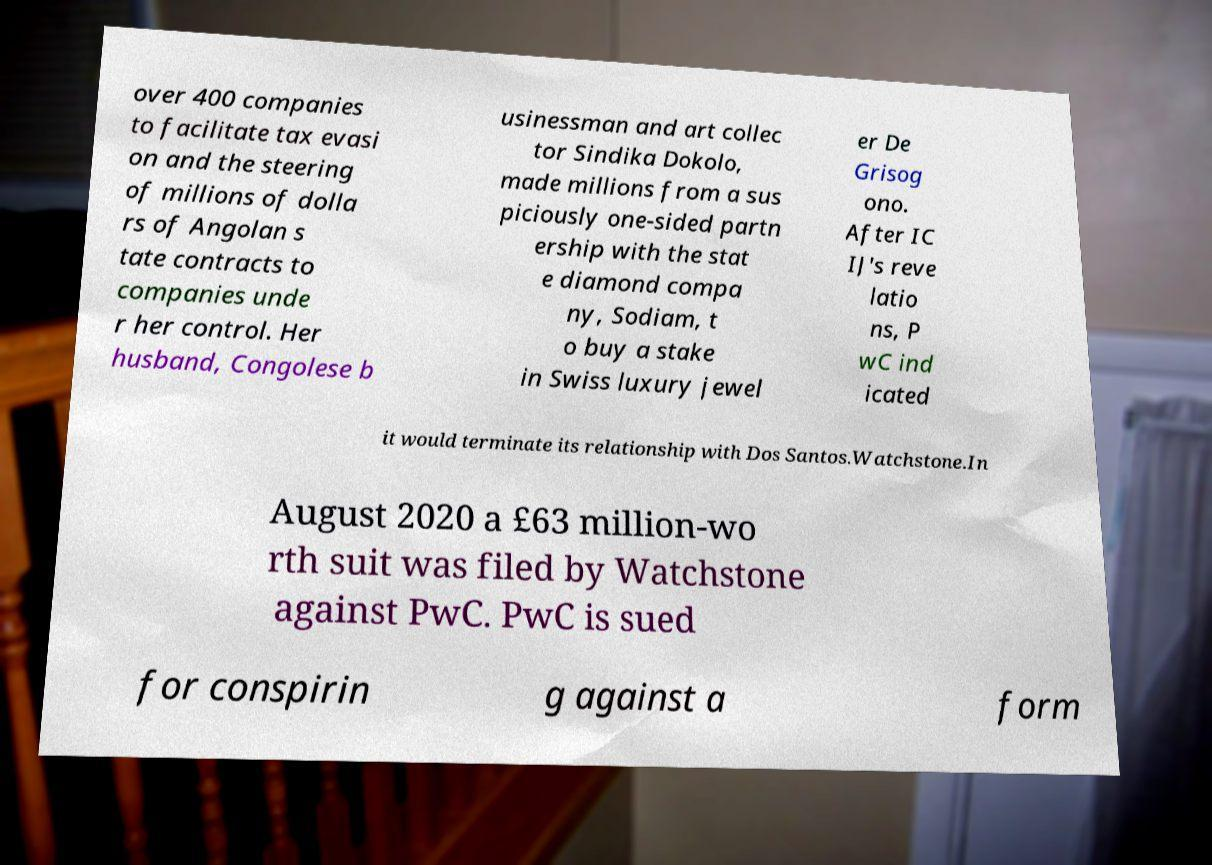Can you accurately transcribe the text from the provided image for me? over 400 companies to facilitate tax evasi on and the steering of millions of dolla rs of Angolan s tate contracts to companies unde r her control. Her husband, Congolese b usinessman and art collec tor Sindika Dokolo, made millions from a sus piciously one-sided partn ership with the stat e diamond compa ny, Sodiam, t o buy a stake in Swiss luxury jewel er De Grisog ono. After IC IJ's reve latio ns, P wC ind icated it would terminate its relationship with Dos Santos.Watchstone.In August 2020 a £63 million-wo rth suit was filed by Watchstone against PwC. PwC is sued for conspirin g against a form 